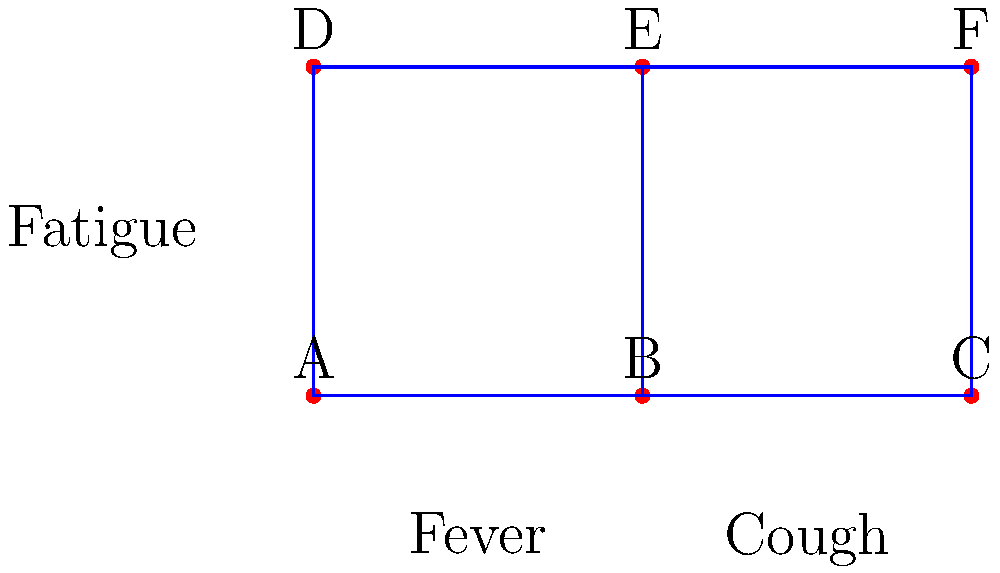In the topological space representing symptom clusters for medical conditions, points A, B, and C form one connected component, while D, E, and F form another. Given that the connections between points represent similarities in symptoms, and the labels indicate common symptoms, which of the following statements is most likely true?

a) Conditions represented by points A and F are more closely related than those represented by points A and B.
b) The condition represented by point E is likely to involve both cough and fatigue symptoms.
c) Conditions represented by points C and F are completely unrelated in terms of symptoms.
d) The topological space suggests that fever and cough are mutually exclusive symptoms. To answer this question, we need to analyze the topological space and the relationships between the points:

1. The space is divided into two connected components: {A, B, C} and {D, E, F}.
2. Points within the same component are directly connected, indicating stronger similarity.
3. The vertical connections (A-D, B-E, C-F) suggest some relationship between the upper and lower components.
4. Symptoms are labeled: Fever between A and B, Cough between B and C, and Fatigue to the left of A and D.

Let's evaluate each option:

a) False. A and B are directly connected in the same component, indicating a closer relationship than A and F, which are in different components.

b) True. Point E is connected to B (associated with cough) and is in the same component as F, which is vertically aligned with C (also associated with cough). Additionally, E is in the upper component, which is closer to the "Fatigue" label.

c) False. While C and F are in different components, they are vertically aligned, suggesting some similarity in symptoms, likely related to cough.

d) False. The topological space shows fever and cough as adjacent symptoms in the lower component, suggesting they can co-occur rather than being mutually exclusive.

Therefore, the most likely true statement is option b.
Answer: b 